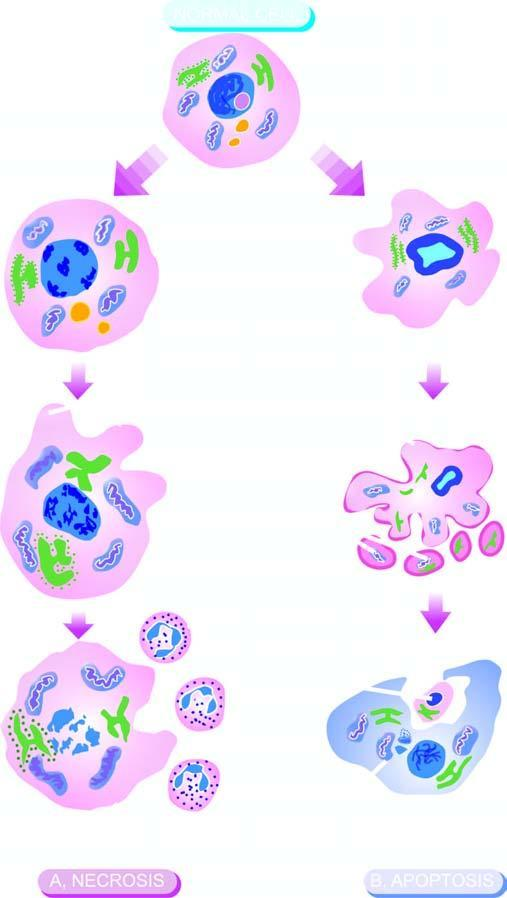what consists of condensation of nuclear chromatin and fragmentation of the cell into membrane-bound apoptotic bodies which are engulfed by macrophages?
Answer the question using a single word or phrase. Apoptosis 